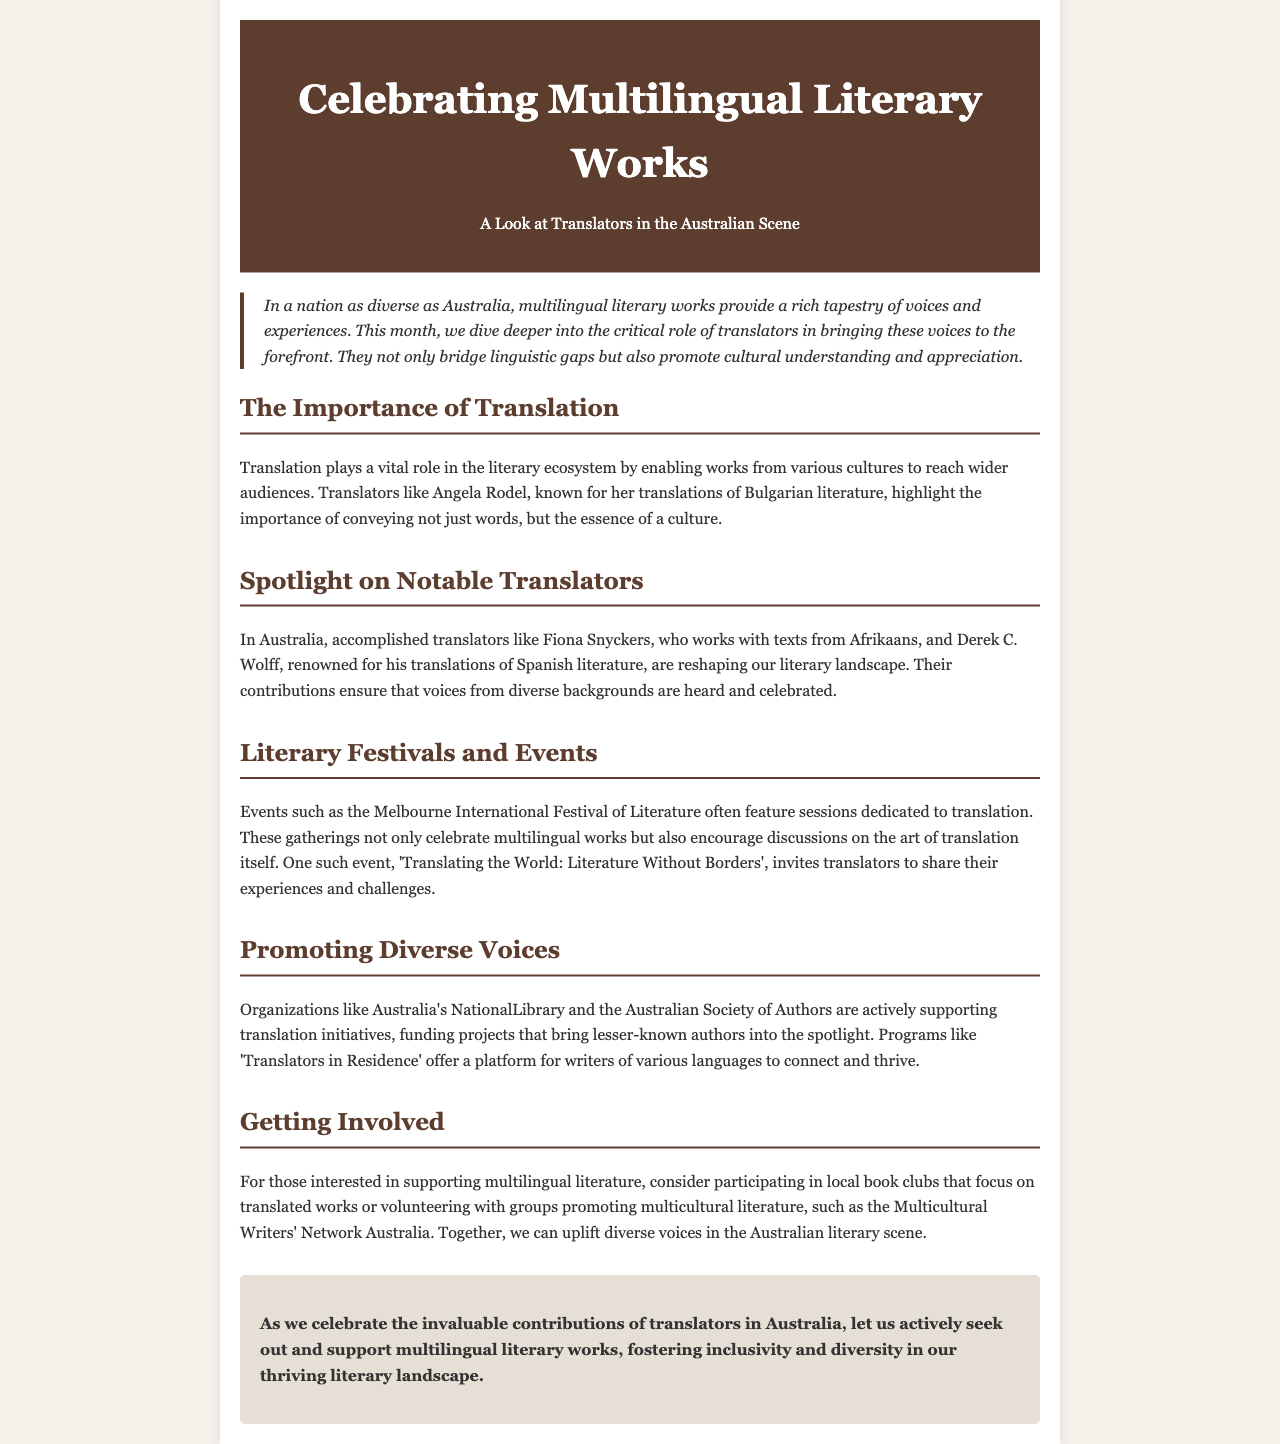What is the main theme of the newsletter? The newsletter focuses on the role of translators in the Australian literary scene and celebrates multilingual literary works.
Answer: Celebrating Multilingual Literary Works Who is a notable translator mentioned for Bulgarian literature? Angela Rodel is identified as a translator known for her work with Bulgarian literature in the document.
Answer: Angela Rodel Which organization supports translation initiatives in Australia? The document states that Australia's National Library is one of the organizations supporting translation initiatives.
Answer: Australia's National Library What event celebrates multilingual literature? The Melbourne International Festival of Literature is highlighted as an event that celebrates multilingual literature and features translation discussions.
Answer: Melbourne International Festival of Literature Who works with texts from Afrikaans? Fiona Snyckers is mentioned as the translator who works with texts from Afrikaans.
Answer: Fiona Snyckers What program connects writers of various languages? The 'Translators in Residence' program offers a platform for writers of various languages to connect.
Answer: Translators in Residence What is the purpose of book clubs mentioned in the newsletter? Local book clubs focusing on translated works aim to support multilingual literature.
Answer: Support multilingual literature What is the concluding instruction in the newsletter? The conclusion suggests actively seeking out and supporting multilingual literary works to foster inclusivity and diversity.
Answer: Actively seek out and support multilingual literary works 